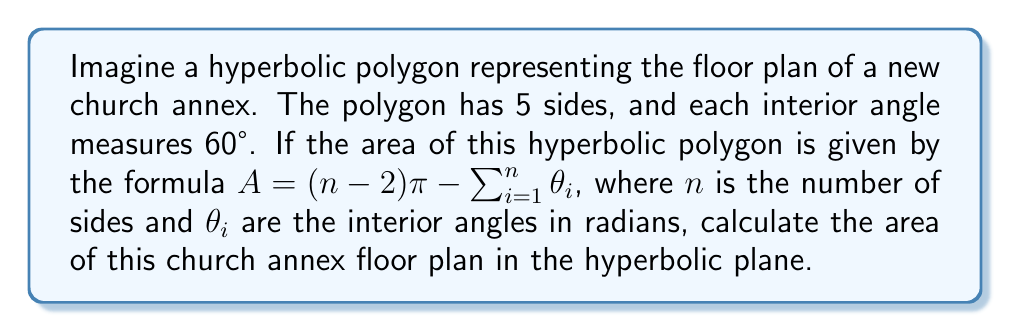Give your solution to this math problem. To solve this problem, let's follow these steps:

1) First, we need to convert the given angle from degrees to radians:
   $60° = \frac{\pi}{3}$ radians

2) We know that $n = 5$ (number of sides)

3) Now, let's calculate the sum of all interior angles in radians:
   $\sum_{i=1}^n \theta_i = 5 \cdot \frac{\pi}{3} = \frac{5\pi}{3}$

4) We can now substitute these values into the given formula:
   $A = (n-2)\pi - \sum_{i=1}^n \theta_i$
   $A = (5-2)\pi - \frac{5\pi}{3}$

5) Simplify:
   $A = 3\pi - \frac{5\pi}{3}$
   $A = \frac{9\pi}{3} - \frac{5\pi}{3}$
   $A = \frac{4\pi}{3}$

Therefore, the area of the hyperbolic polygon representing the church annex floor plan is $\frac{4\pi}{3}$.
Answer: $\frac{4\pi}{3}$ 